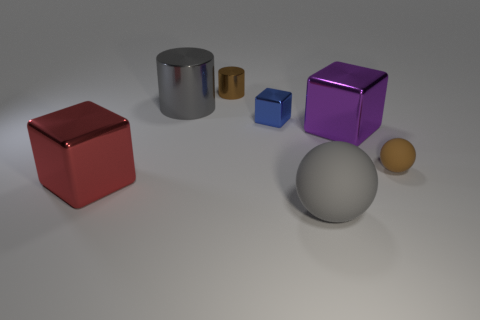Subtract all big blocks. How many blocks are left? 1 Add 1 yellow metal blocks. How many objects exist? 8 Subtract all cubes. How many objects are left? 4 Subtract all small shiny cylinders. Subtract all tiny metal objects. How many objects are left? 4 Add 5 gray things. How many gray things are left? 7 Add 5 brown rubber spheres. How many brown rubber spheres exist? 6 Subtract 1 blue cubes. How many objects are left? 6 